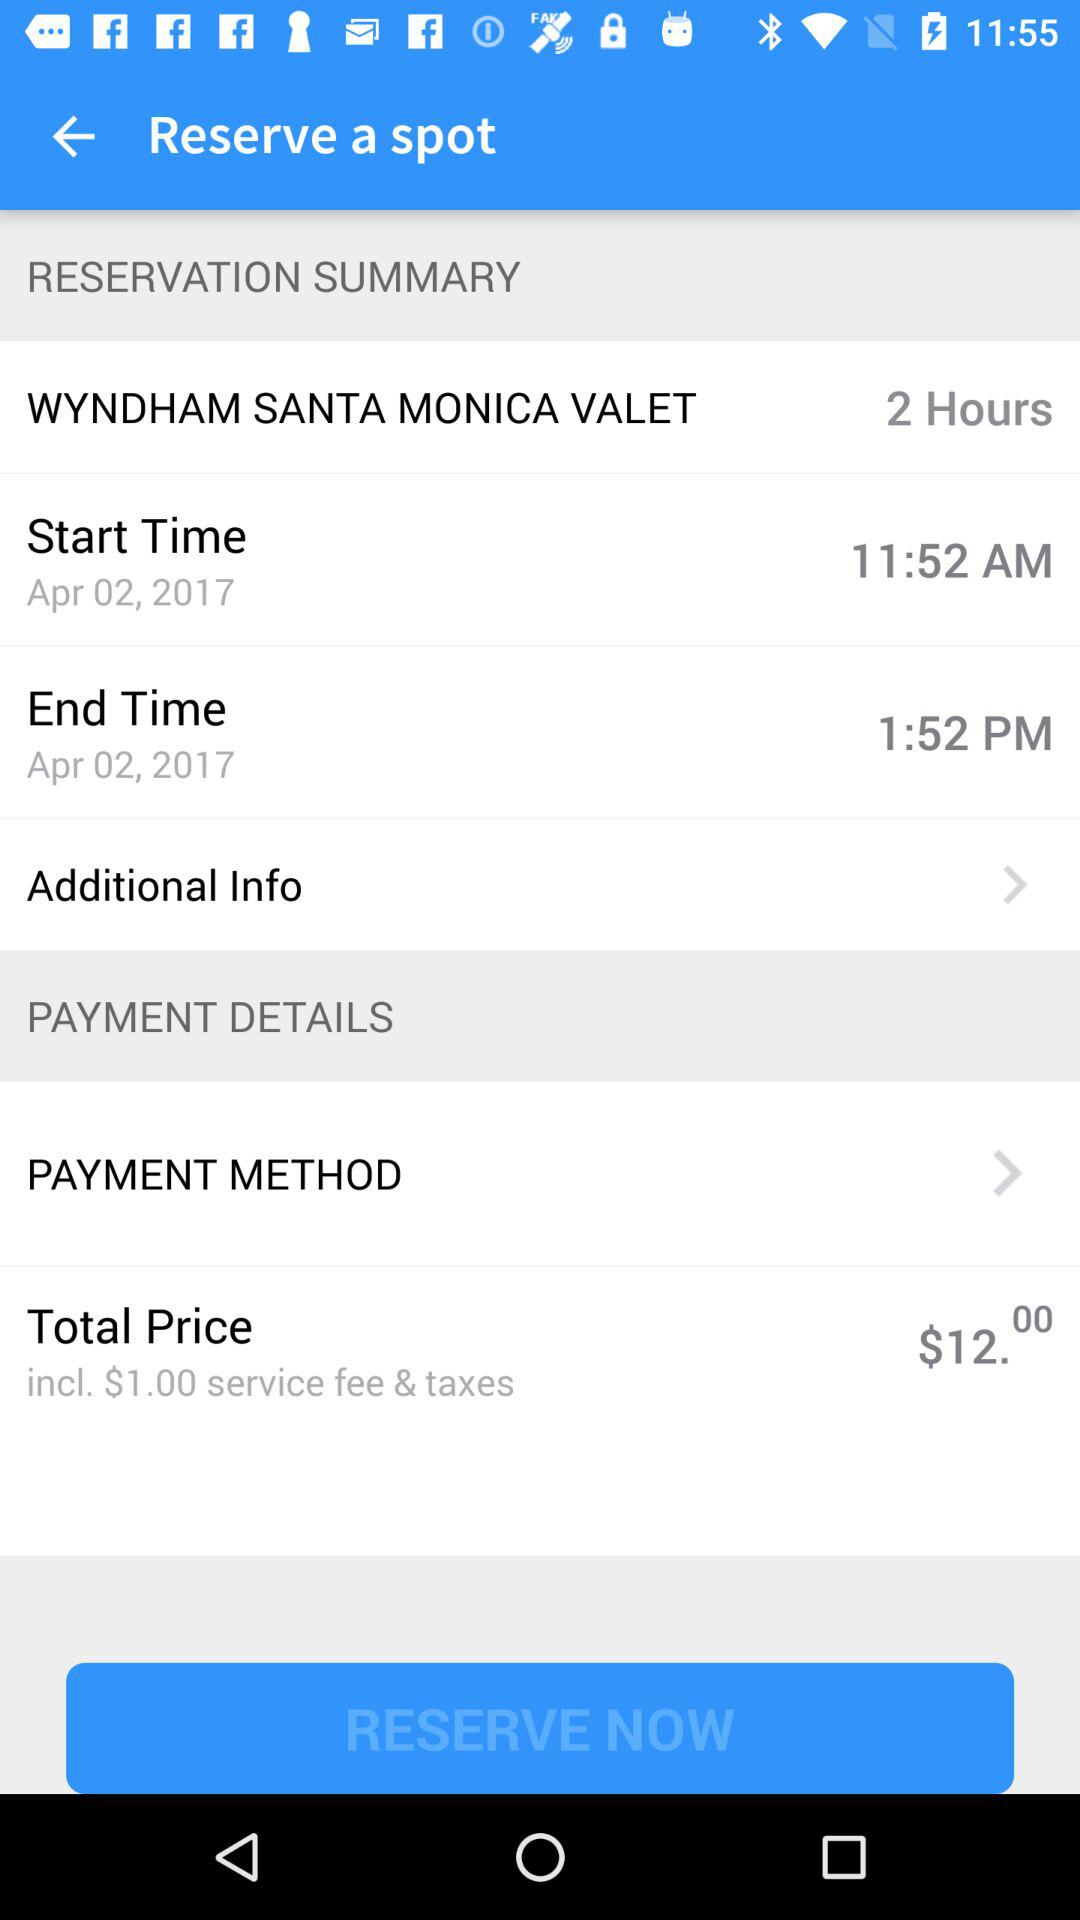How much is the total price of the reservation?
Answer the question using a single word or phrase. $12.00 